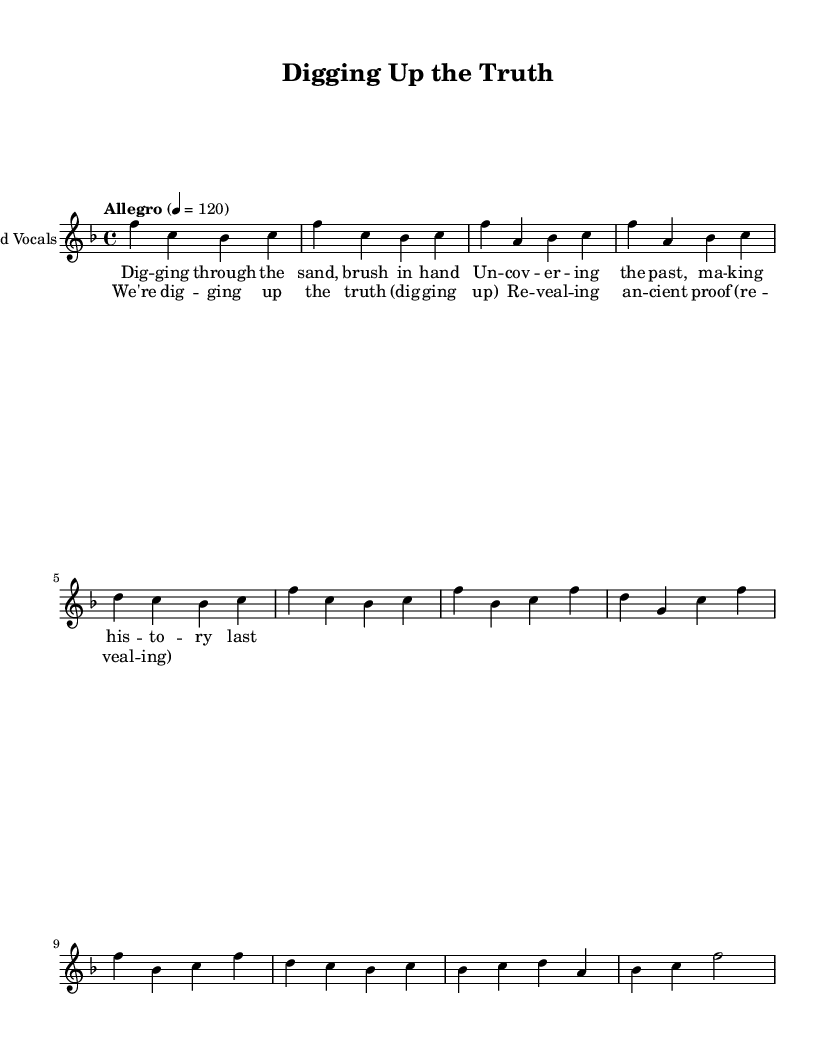What is the key signature of this music? The key signature is F major, which has one flat (B flat). The presence of the B flat note in the melody further confirms this key.
Answer: F major What is the time signature used in this piece? The time signature is 4/4, indicating four beats per measure. This can be seen at the beginning of the music section.
Answer: 4/4 What is the tempo marking for this piece? The tempo marking is "Allegro" at a speed of 120 beats per minute. This is explicitly stated in the tempo notation in the music sheet.
Answer: Allegro 120 How many sections are there in this music piece? There are four sections: Intro, Verse, Chorus, and Bridge. Each section is distinctly named and contributes to the overall structure.
Answer: Four How many syllables are in the chorus line "We're digging up the truth"? The chorus line contains seven syllables. Counting the syllables in each word confirms this total.
Answer: Seven What is the primary theme expressed in the lyrics of this song? The primary theme is the exploration and revelation of history through archaeology. The lyrics emphasize uncovering the truth about the past.
Answer: Archaeology What is the specific mood conveyed by the tempo and melody of the music? The upbeat tempo of 120 BPM combined with a lively melody creates a celebratory and joyful mood, reflecting excitement about archaeological discoveries.
Answer: Joyful 